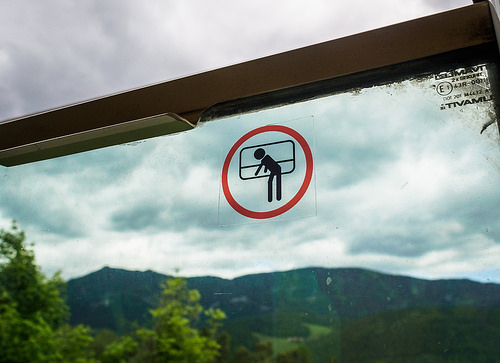<image>
Is the sky next to the mountains? No. The sky is not positioned next to the mountains. They are located in different areas of the scene. 